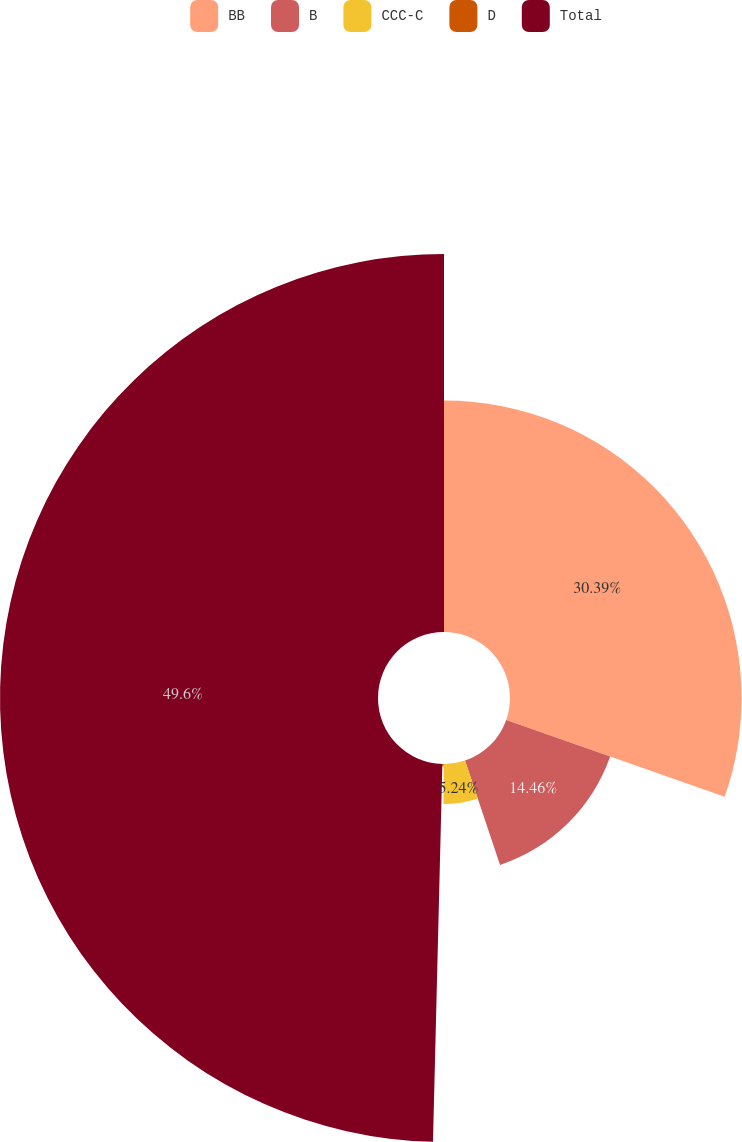Convert chart. <chart><loc_0><loc_0><loc_500><loc_500><pie_chart><fcel>BB<fcel>B<fcel>CCC-C<fcel>D<fcel>Total<nl><fcel>30.39%<fcel>14.46%<fcel>5.24%<fcel>0.31%<fcel>49.61%<nl></chart> 